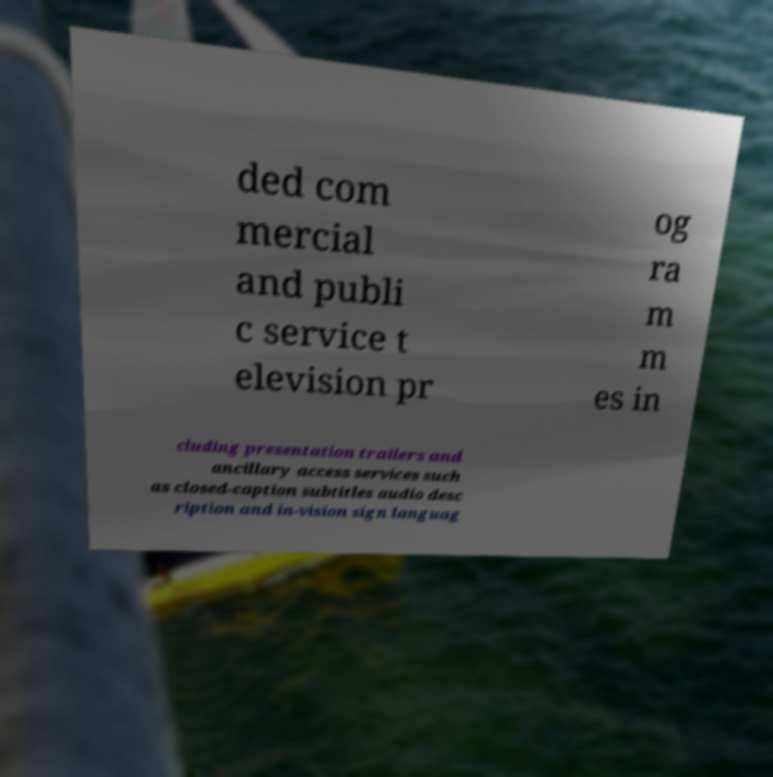Could you assist in decoding the text presented in this image and type it out clearly? ded com mercial and publi c service t elevision pr og ra m m es in cluding presentation trailers and ancillary access services such as closed-caption subtitles audio desc ription and in-vision sign languag 